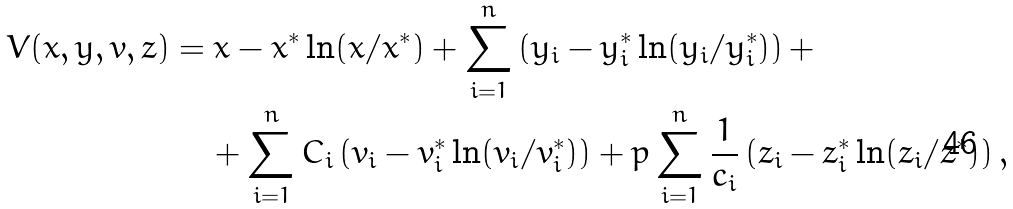<formula> <loc_0><loc_0><loc_500><loc_500>V ( x , y , v , z ) & = x - x ^ { * } \ln ( x / x ^ { * } ) + \sum _ { i = 1 } ^ { n } \left ( y _ { i } - y _ { i } ^ { * } \ln ( y _ { i } / y _ { i } ^ { * } ) \right ) + \\ & \quad + \sum _ { i = 1 } ^ { n } C _ { i } \left ( v _ { i } - v _ { i } ^ { * } \ln ( v _ { i } / v _ { i } ^ { * } ) \right ) + p \sum _ { i = 1 } ^ { n } \frac { 1 } { c _ { i } } \left ( z _ { i } - z _ { i } ^ { * } \ln ( z _ { i } / z ^ { * } ) \right ) ,</formula> 